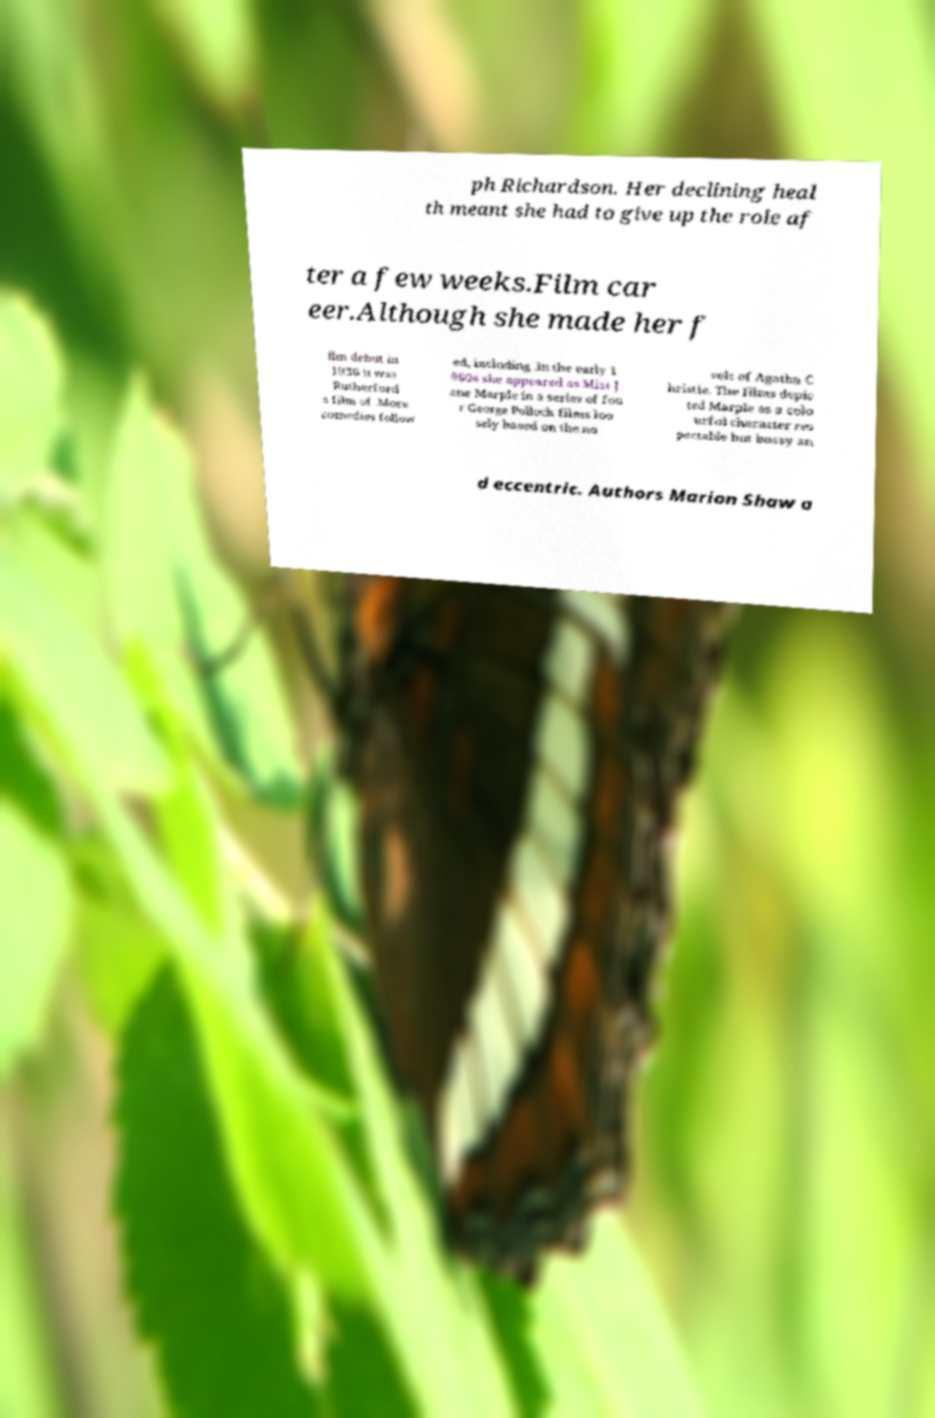There's text embedded in this image that I need extracted. Can you transcribe it verbatim? ph Richardson. Her declining heal th meant she had to give up the role af ter a few weeks.Film car eer.Although she made her f ilm debut in 1936 it was Rutherford s film of .More comedies follow ed, including .In the early 1 960s she appeared as Miss J ane Marple in a series of fou r George Pollock films loo sely based on the no vels of Agatha C hristie. The films depic ted Marple as a colo urful character res pectable but bossy an d eccentric. Authors Marion Shaw a 